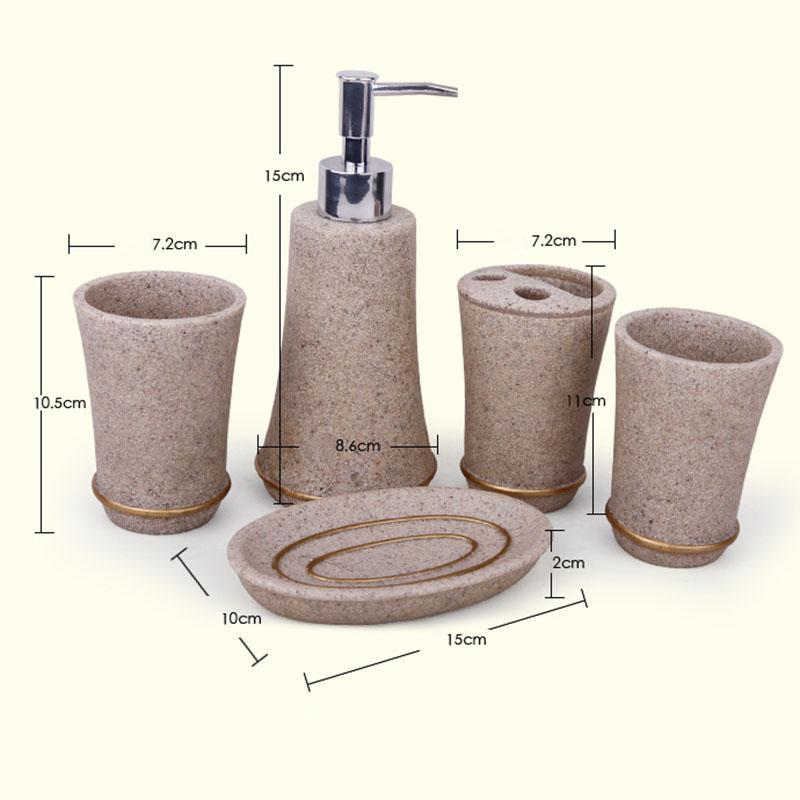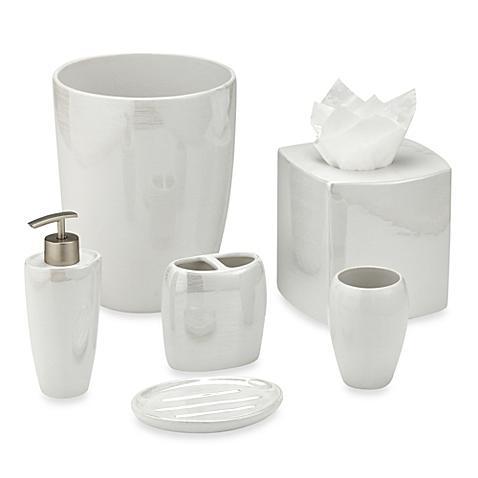The first image is the image on the left, the second image is the image on the right. Considering the images on both sides, is "The image on the right contains a grouping of four containers with a pump in the center of the back row of three." valid? Answer yes or no. No. 